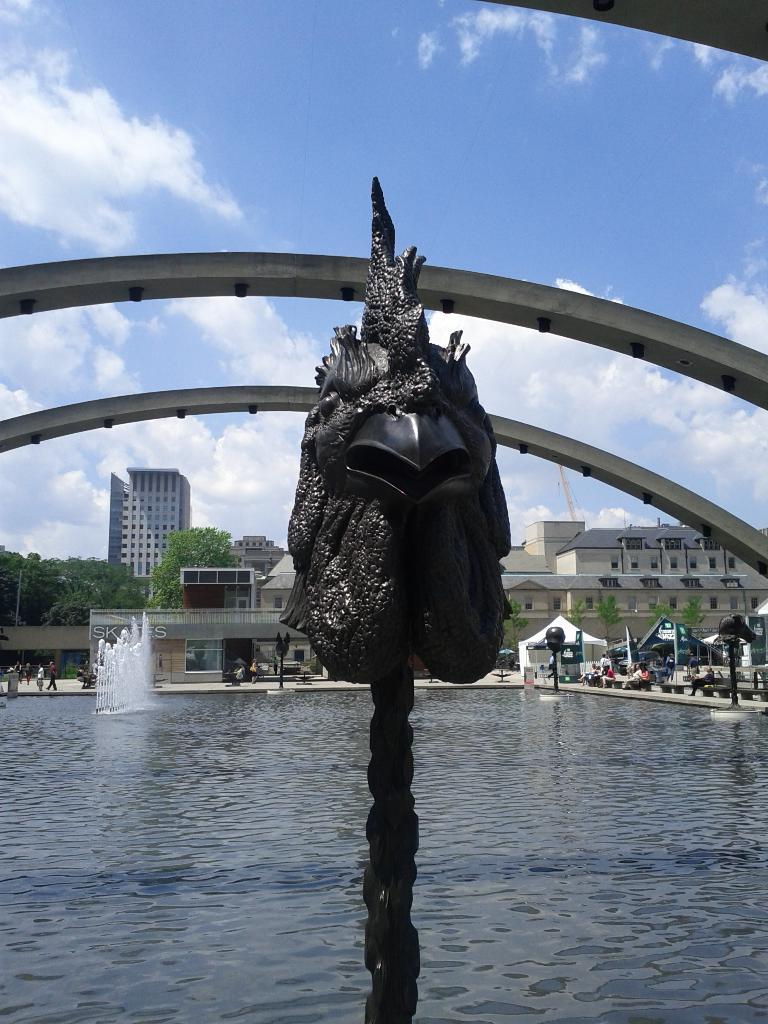What is the main feature in the image? There is a fountain in the image. What is at the bottom of the fountain? There is water at the bottom of the fountain. What architectural element can be seen in the image? There is an arch in the image. What can be seen in the background of the image? There are buildings, tents, trees, and the sky visible in the background of the image. How many pets are participating in the competition in the image? There are no pets or competition present in the image. What type of cow can be seen grazing near the fountain in the image? There are no cows present in the image; it features a fountain, an arch, and various background elements. 